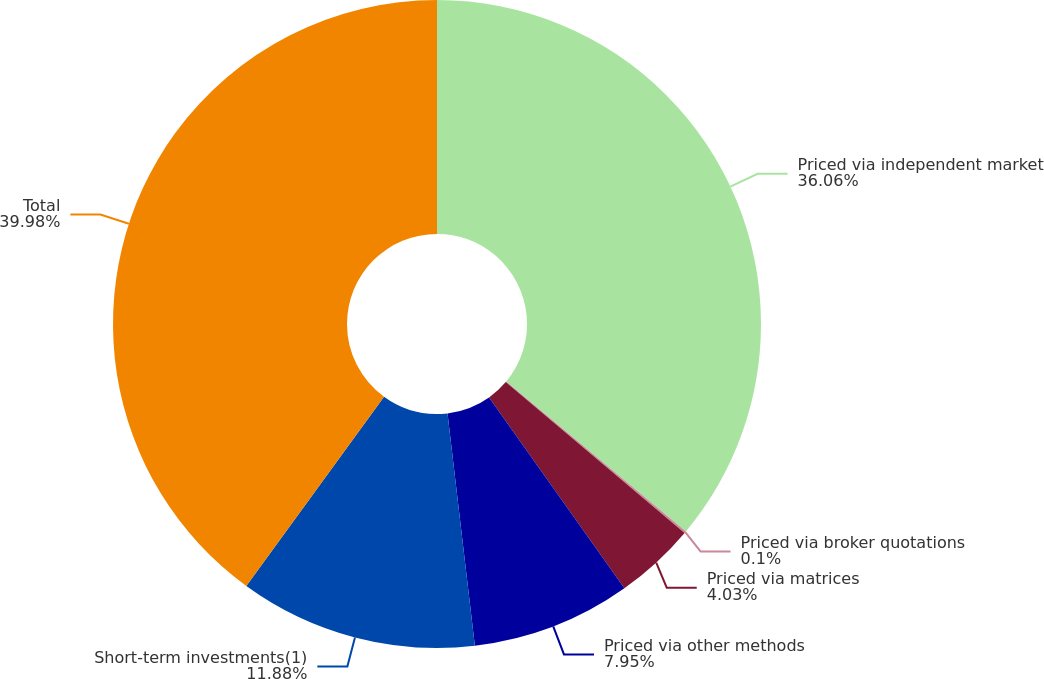Convert chart. <chart><loc_0><loc_0><loc_500><loc_500><pie_chart><fcel>Priced via independent market<fcel>Priced via broker quotations<fcel>Priced via matrices<fcel>Priced via other methods<fcel>Short-term investments(1)<fcel>Total<nl><fcel>36.06%<fcel>0.1%<fcel>4.03%<fcel>7.95%<fcel>11.88%<fcel>39.99%<nl></chart> 